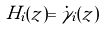<formula> <loc_0><loc_0><loc_500><loc_500>H _ { i } ( z ) = \dot { \gamma } _ { i } ( z )</formula> 